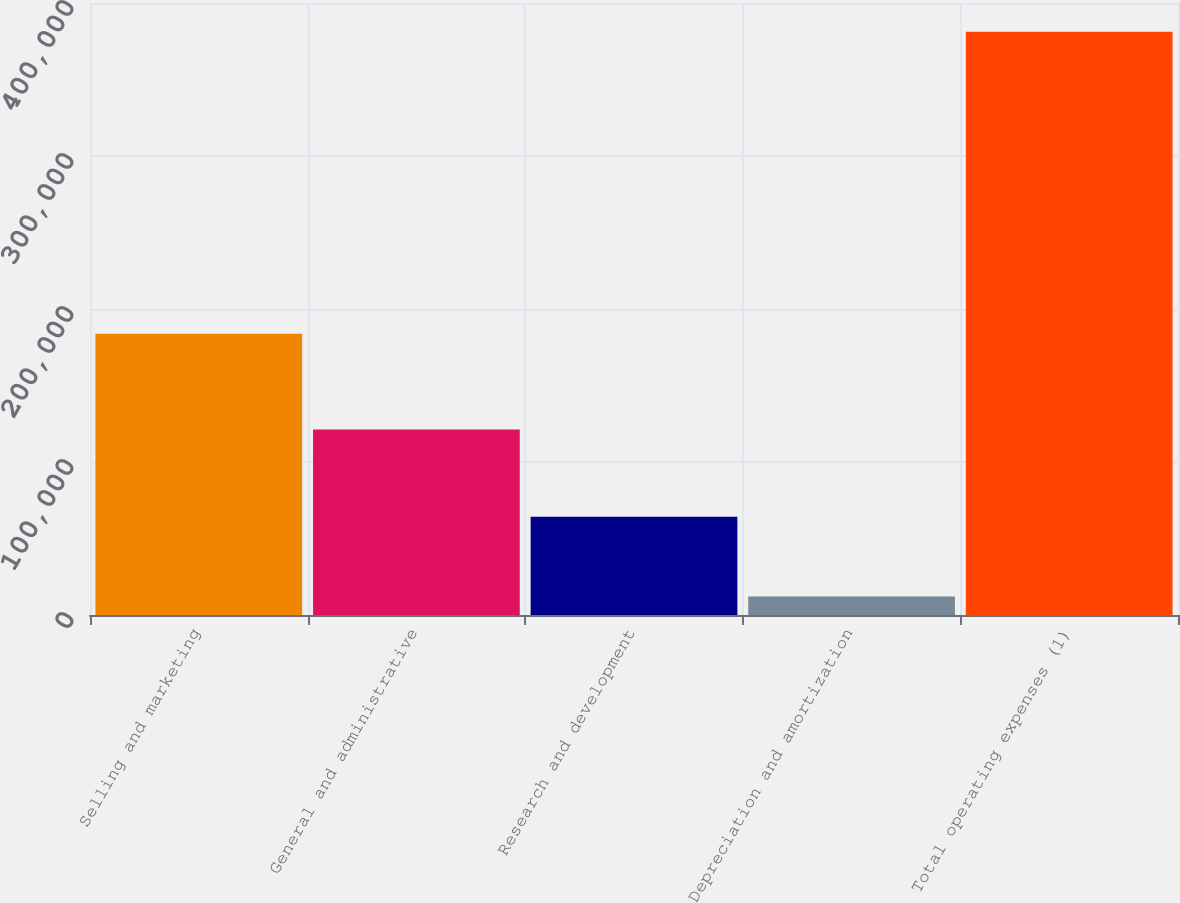Convert chart. <chart><loc_0><loc_0><loc_500><loc_500><bar_chart><fcel>Selling and marketing<fcel>General and administrative<fcel>Research and development<fcel>Depreciation and amortization<fcel>Total operating expenses (1)<nl><fcel>183749<fcel>121200<fcel>64162<fcel>12123<fcel>381234<nl></chart> 